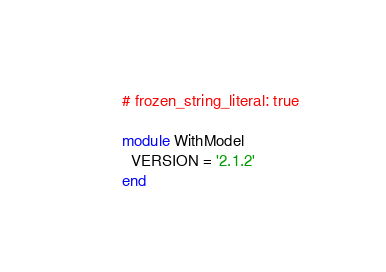Convert code to text. <code><loc_0><loc_0><loc_500><loc_500><_Ruby_># frozen_string_literal: true

module WithModel
  VERSION = '2.1.2'
end
</code> 